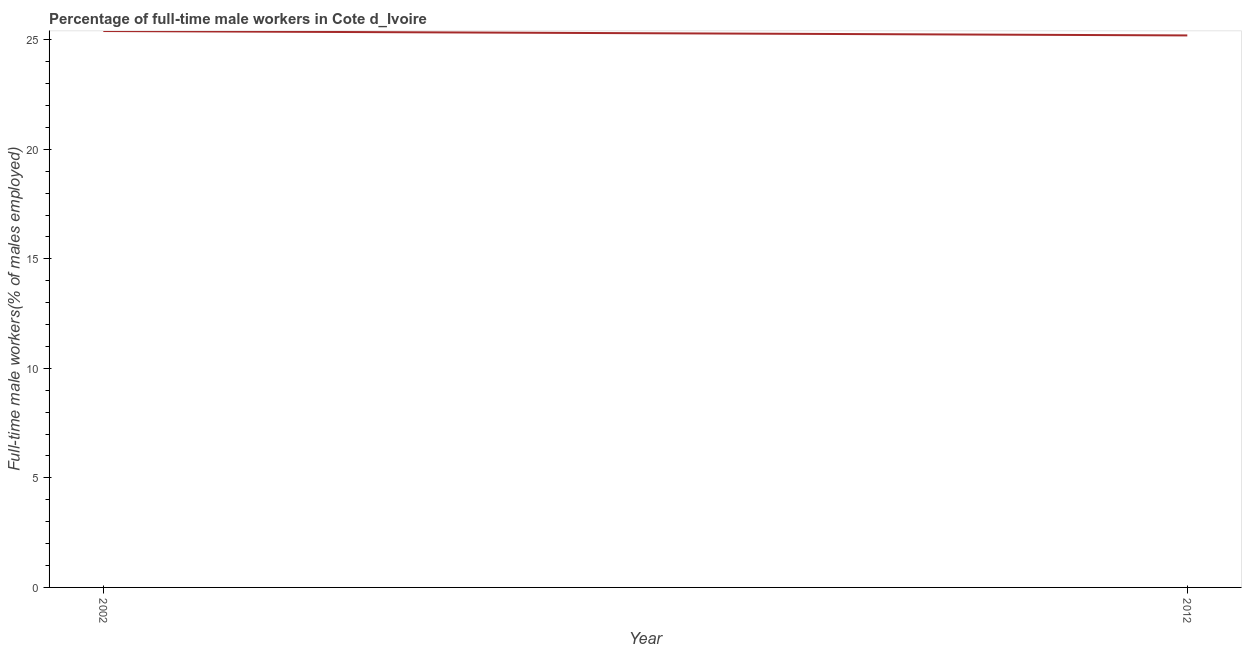What is the percentage of full-time male workers in 2002?
Give a very brief answer. 25.4. Across all years, what is the maximum percentage of full-time male workers?
Your answer should be compact. 25.4. Across all years, what is the minimum percentage of full-time male workers?
Give a very brief answer. 25.2. In which year was the percentage of full-time male workers maximum?
Offer a very short reply. 2002. In which year was the percentage of full-time male workers minimum?
Offer a very short reply. 2012. What is the sum of the percentage of full-time male workers?
Offer a terse response. 50.6. What is the difference between the percentage of full-time male workers in 2002 and 2012?
Ensure brevity in your answer.  0.2. What is the average percentage of full-time male workers per year?
Ensure brevity in your answer.  25.3. What is the median percentage of full-time male workers?
Ensure brevity in your answer.  25.3. What is the ratio of the percentage of full-time male workers in 2002 to that in 2012?
Make the answer very short. 1.01. In how many years, is the percentage of full-time male workers greater than the average percentage of full-time male workers taken over all years?
Your answer should be very brief. 1. How many years are there in the graph?
Ensure brevity in your answer.  2. Are the values on the major ticks of Y-axis written in scientific E-notation?
Provide a short and direct response. No. Does the graph contain any zero values?
Offer a terse response. No. What is the title of the graph?
Your answer should be compact. Percentage of full-time male workers in Cote d_Ivoire. What is the label or title of the X-axis?
Provide a short and direct response. Year. What is the label or title of the Y-axis?
Your response must be concise. Full-time male workers(% of males employed). What is the Full-time male workers(% of males employed) in 2002?
Make the answer very short. 25.4. What is the Full-time male workers(% of males employed) of 2012?
Make the answer very short. 25.2. 